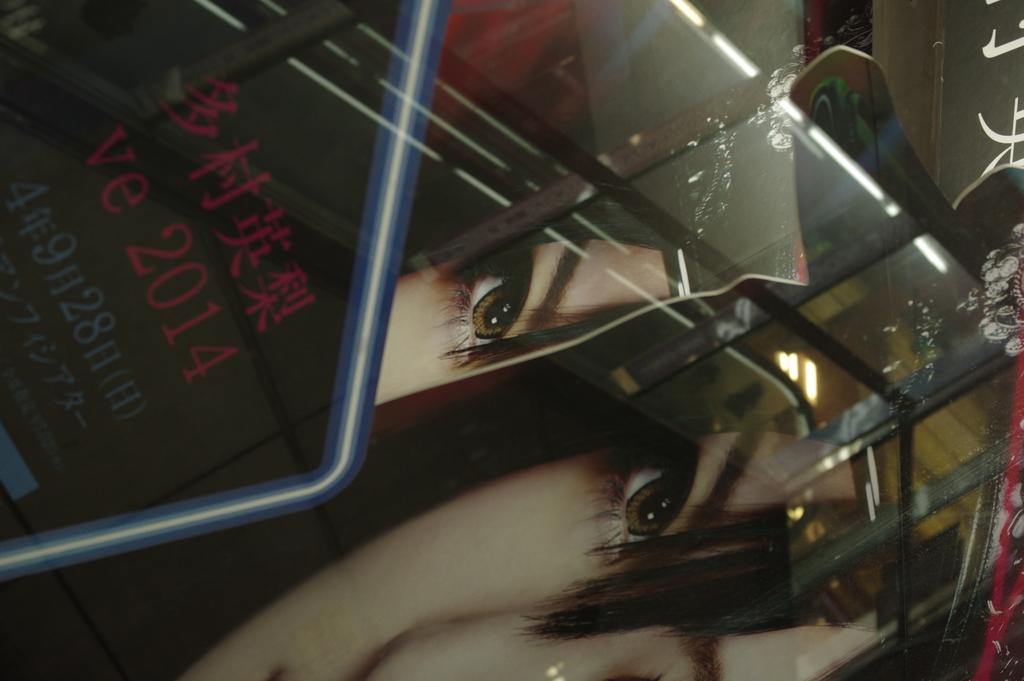What is the main subject of the image? There is a person's face in the image. Can you describe any text or writing in the image? Yes, there is something written on an object in the image. What can be seen in terms of illumination in the image? There are lights visible in the image. What else is present in the image besides the person's face and the written object? There are other objects present in the image. How does the person's face express anger in the image? The person's face does not express anger in the image, as there is no indication of emotion in the provided facts. What type of toothbrush is being used by the person in the image? There is no toothbrush present in the image. 